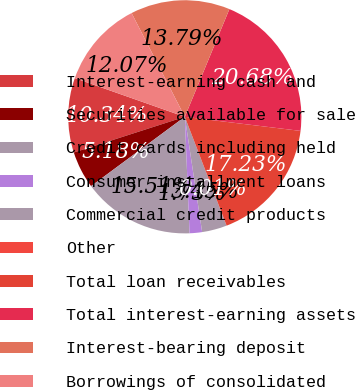<chart> <loc_0><loc_0><loc_500><loc_500><pie_chart><fcel>Interest-earning cash and<fcel>Securities available for sale<fcel>Credit cards including held<fcel>Consumer installment loans<fcel>Commercial credit products<fcel>Other<fcel>Total loan receivables<fcel>Total interest-earning assets<fcel>Interest-bearing deposit<fcel>Borrowings of consolidated<nl><fcel>10.34%<fcel>5.18%<fcel>15.51%<fcel>1.73%<fcel>3.45%<fcel>0.01%<fcel>17.23%<fcel>20.68%<fcel>13.79%<fcel>12.07%<nl></chart> 